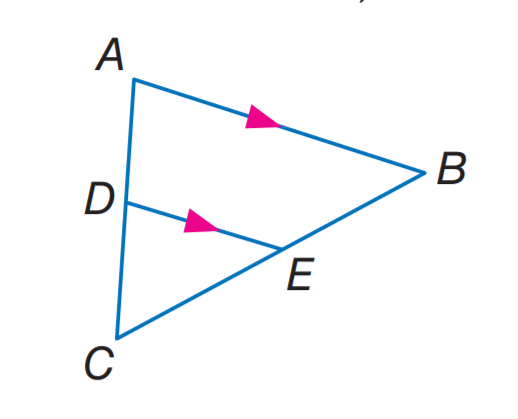Answer the mathemtical geometry problem and directly provide the correct option letter.
Question: If C E = t - 2. E B = t + 1, C D = 2, and C A = 10, find t.
Choices: A: 1 B: 2 C: 3 D: 4 C 